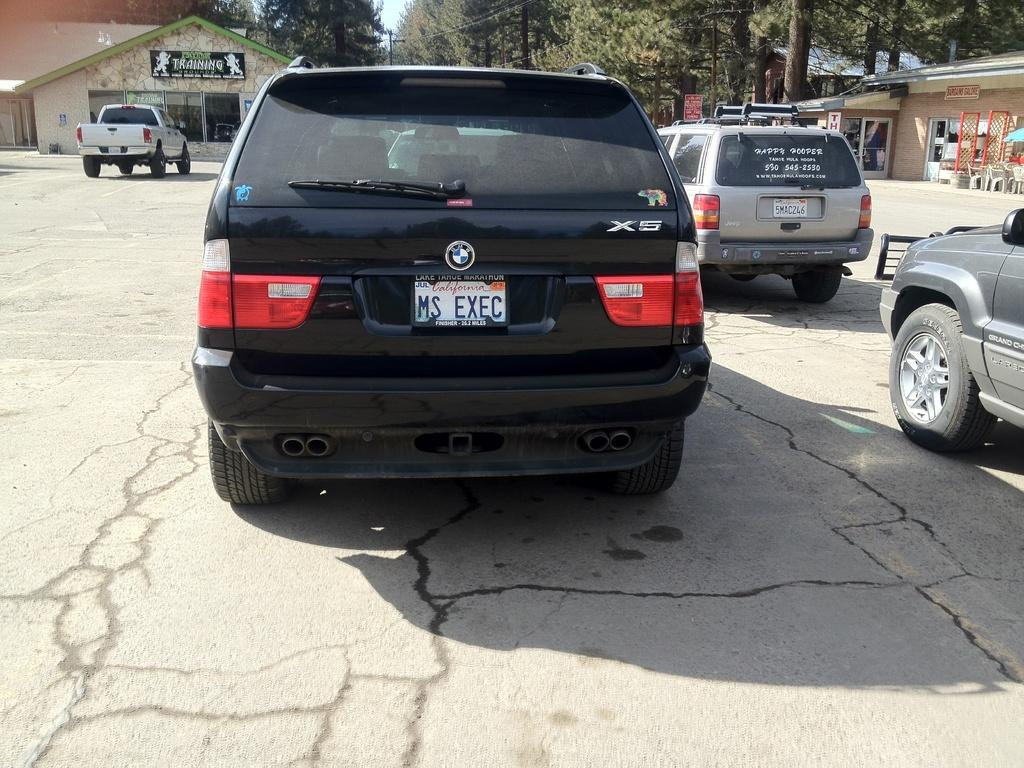Provide a one-sentence caption for the provided image. A black BMW SUV has the license plate Ms Exec. 